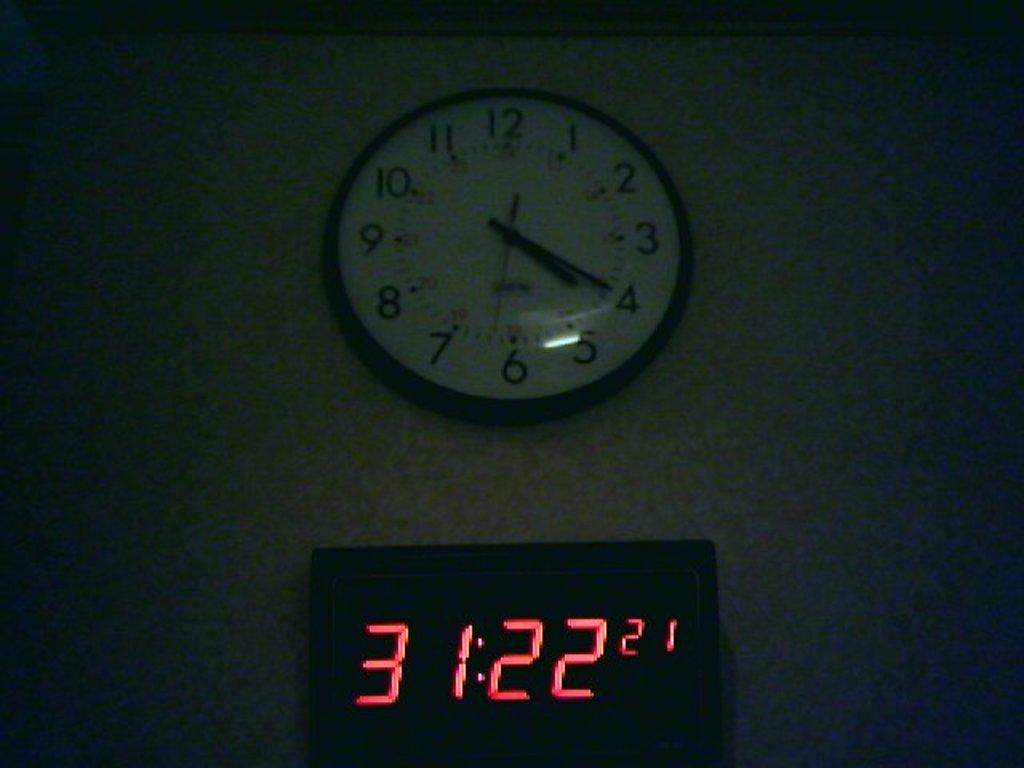What type of timekeeping devices are present in the image? There is a digital clock and a wall clock in the image. Where is the wall clock located? The wall clock is on a wall. What type of coat is draped over the wall clock in the image? There is no coat present in the image; only the digital clock and wall clock are visible. 